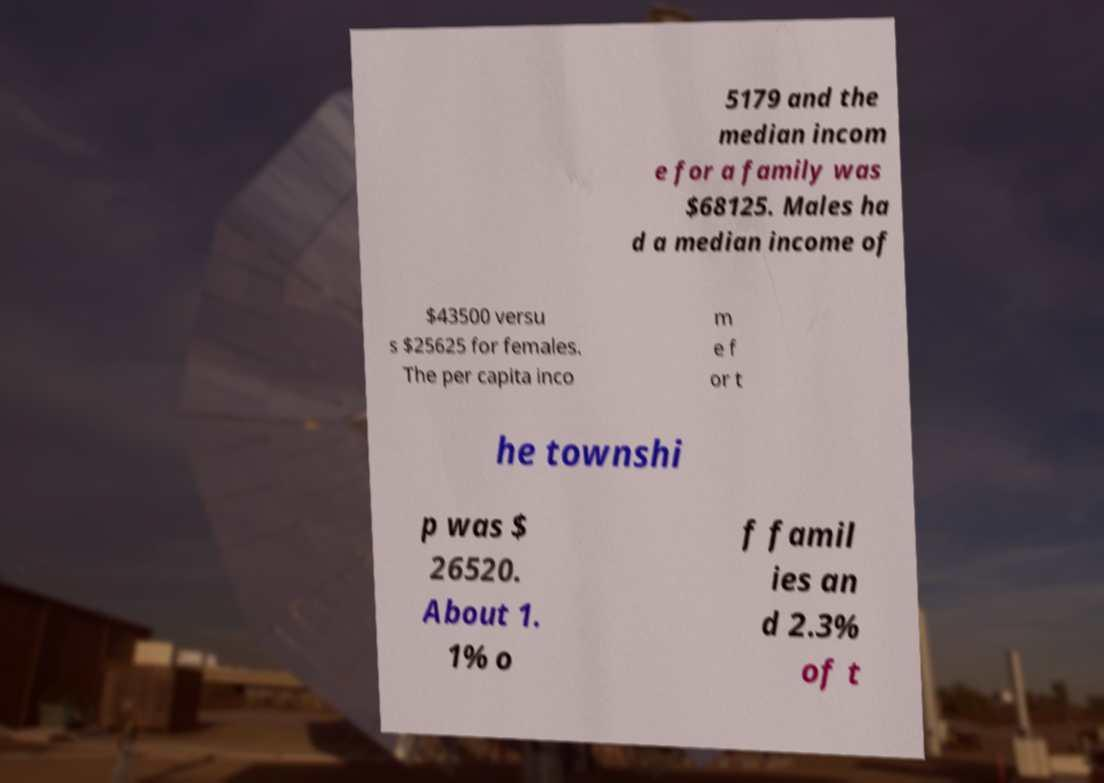What messages or text are displayed in this image? I need them in a readable, typed format. 5179 and the median incom e for a family was $68125. Males ha d a median income of $43500 versu s $25625 for females. The per capita inco m e f or t he townshi p was $ 26520. About 1. 1% o f famil ies an d 2.3% of t 